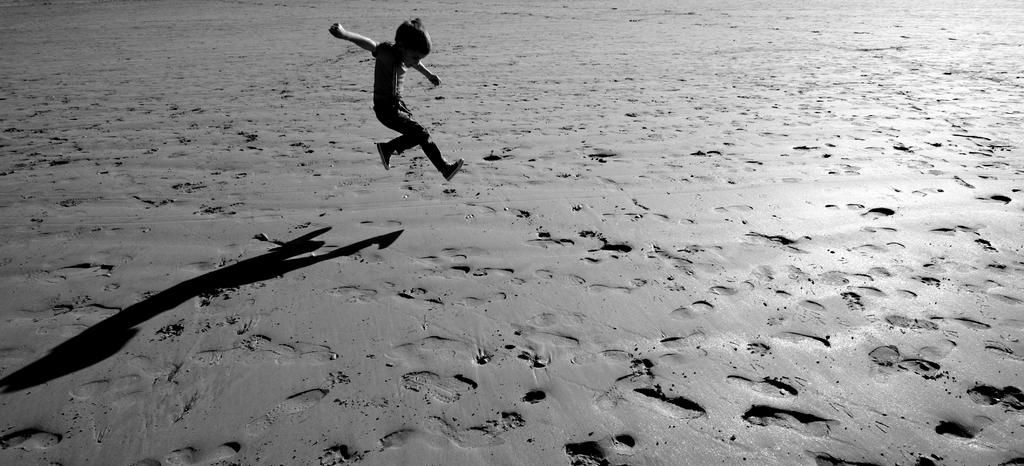Who is the main subject in the image? There is a boy in the image. What is the boy doing in the image? The boy is jumping. What can be seen on the ground in the image? There are footprints and a shadow of the boy on the ground. What type of brick is the boy holding in the image? There is no brick present in the image; the boy is jumping and has no objects in his hands. 